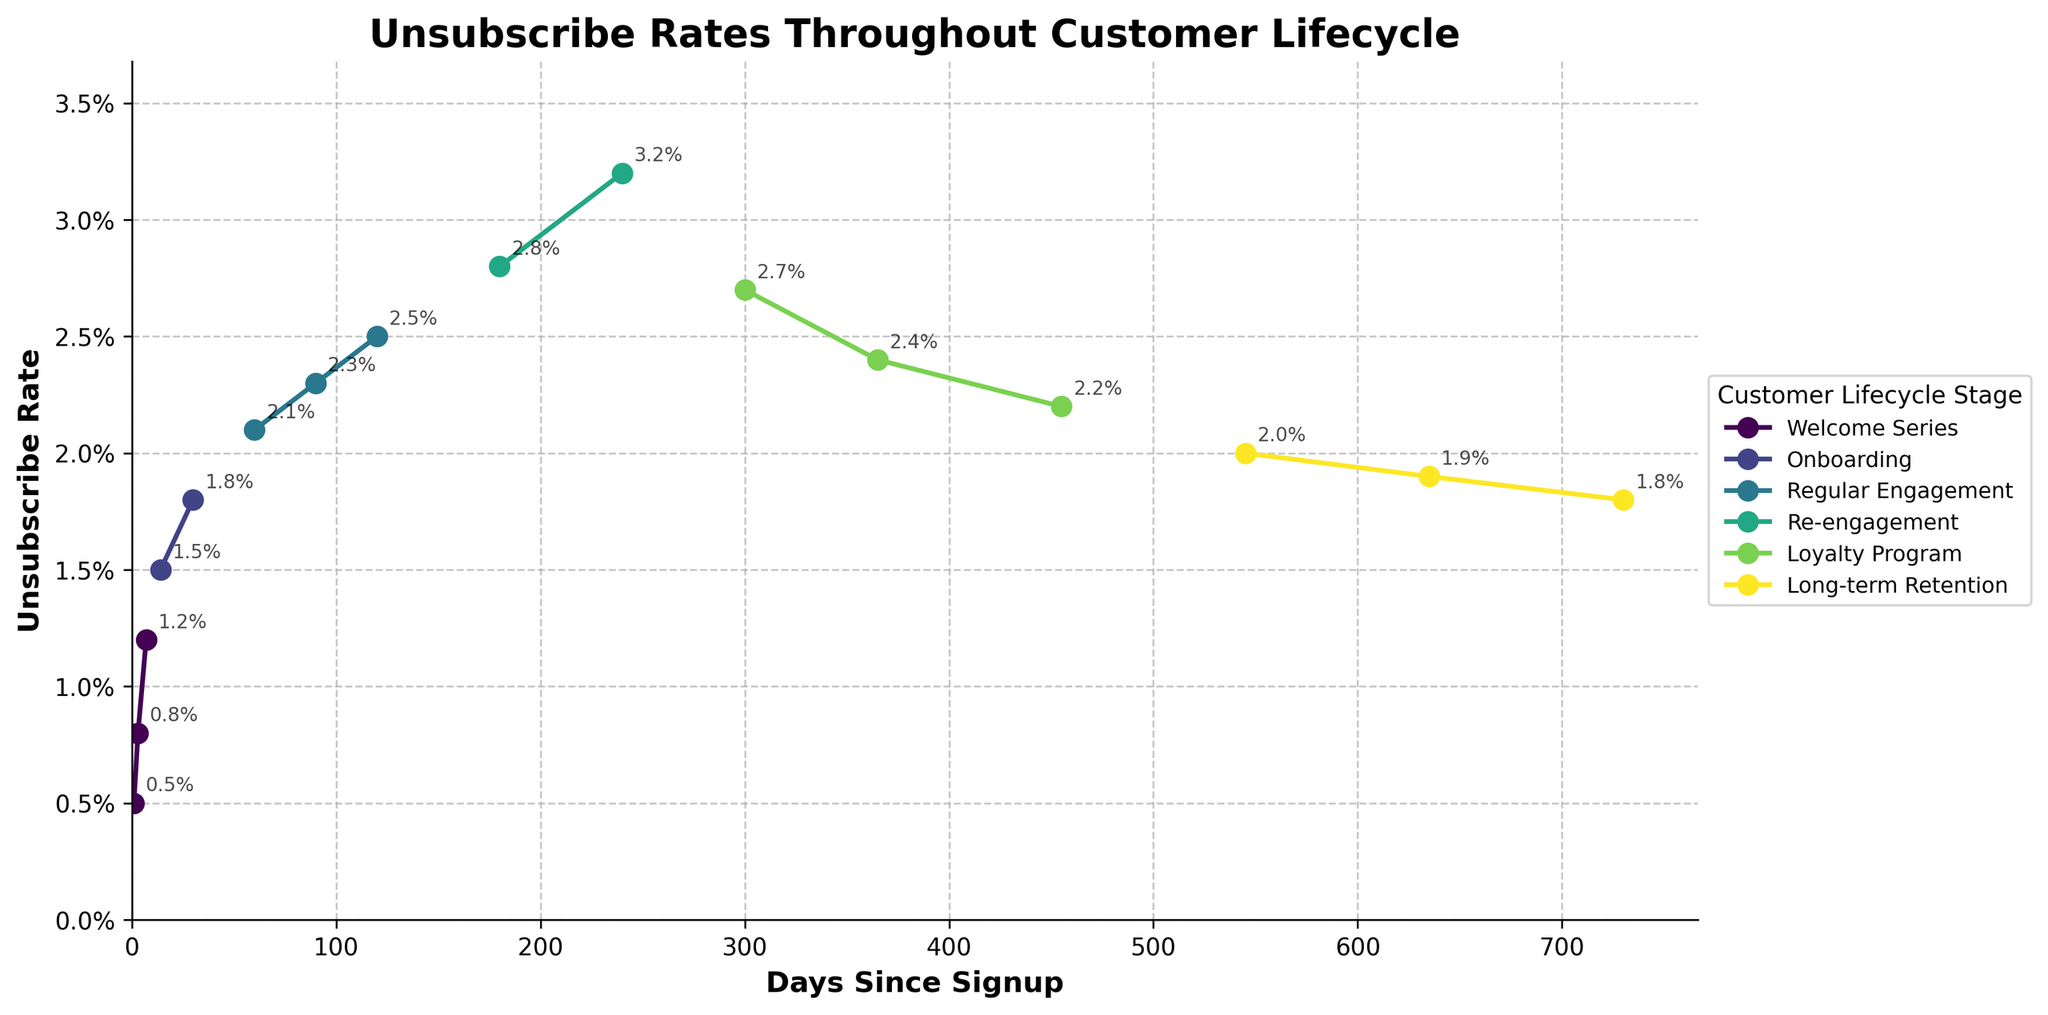What's the unsubscribe rate at the end of the Welcome Series stage? Look at the last data point associated with the Welcome Series stage, which is at 7 days since signup. The unsubscribe rate there is 1.2%.
Answer: 1.2% Which stage has the highest recorded unsubscribe rate? Identify the stage with the highest unsubscribe rate value in the chart. The highest rate is 3.2%, which occurs during the Re-engagement stage at 240 days since signup.
Answer: Re-engagement How does the unsubscribe rate at 120 days compare to that at 635 days? Find the data points for 120 and 635 days since signup. At 120 days, the unsubscribe rate is 2.5%, and at 635 days, it is 1.9%. Compare these values to see that the unsubscribe rate decreases from 2.5% to 1.9%.
Answer: It decreases What's the average unsubscribe rate during the Onboarding stage? Identify the data points in the Onboarding stage (1.5% at 14 days and 1.8% at 30 days). Calculate the average: (1.5% + 1.8%) / 2 = 1.65%.
Answer: 1.65% Between which two adjacent stages does the unsubscribe rate drop the most? Compare the unsubscribe rate values at the transitions between each of the adjacent stages. The largest drop is from Re-engagement to Loyalty Program, from 3.2% to 2.7%, a difference of 0.5%.
Answer: Re-engagement to Loyalty Program Is there any stage where the unsubscribe rate consistently decreases over time? Examine each stage to see if the unsubscribe rate decreases from the beginning to the end of that stage. In the Long-term Retention stage, the unsubscribe rate decreases consistently from 2.0% to 1.8%.
Answer: Long-term Retention At what stage and how many days since signup does the unsubscribe rate begin to decrease after previously increasing? Look for the stage where there is a decrease following an increase in unsubscribe rate values. This occurs in the Loyalty Program stage at 365 days since signup when the rate decreases from 3.2% in the Re-engagement stage.
Answer: Loyalty Program, 365 days Which stage shows a decreasing trend in the unsubscribe rate over time, but not consistently? Identify the stages where the rate overall decreases but shows some fluctuations. The Loyalty Program shows an overall decrease from 3.2% to 2.2% with slight increases at intermediate points (2.7% at 300 days, 2.4% at 365 days).
Answer: Loyalty Program In which stage does the unsubscribe rate increase and then decrease? Analyze each stage to see if the unsubscribe rate increases at first and then later decreases. This occurs in the Welcome Series stage, where the rate increases from 0.5% to 1.2% and decreases from there.
Answer: Welcome Series 